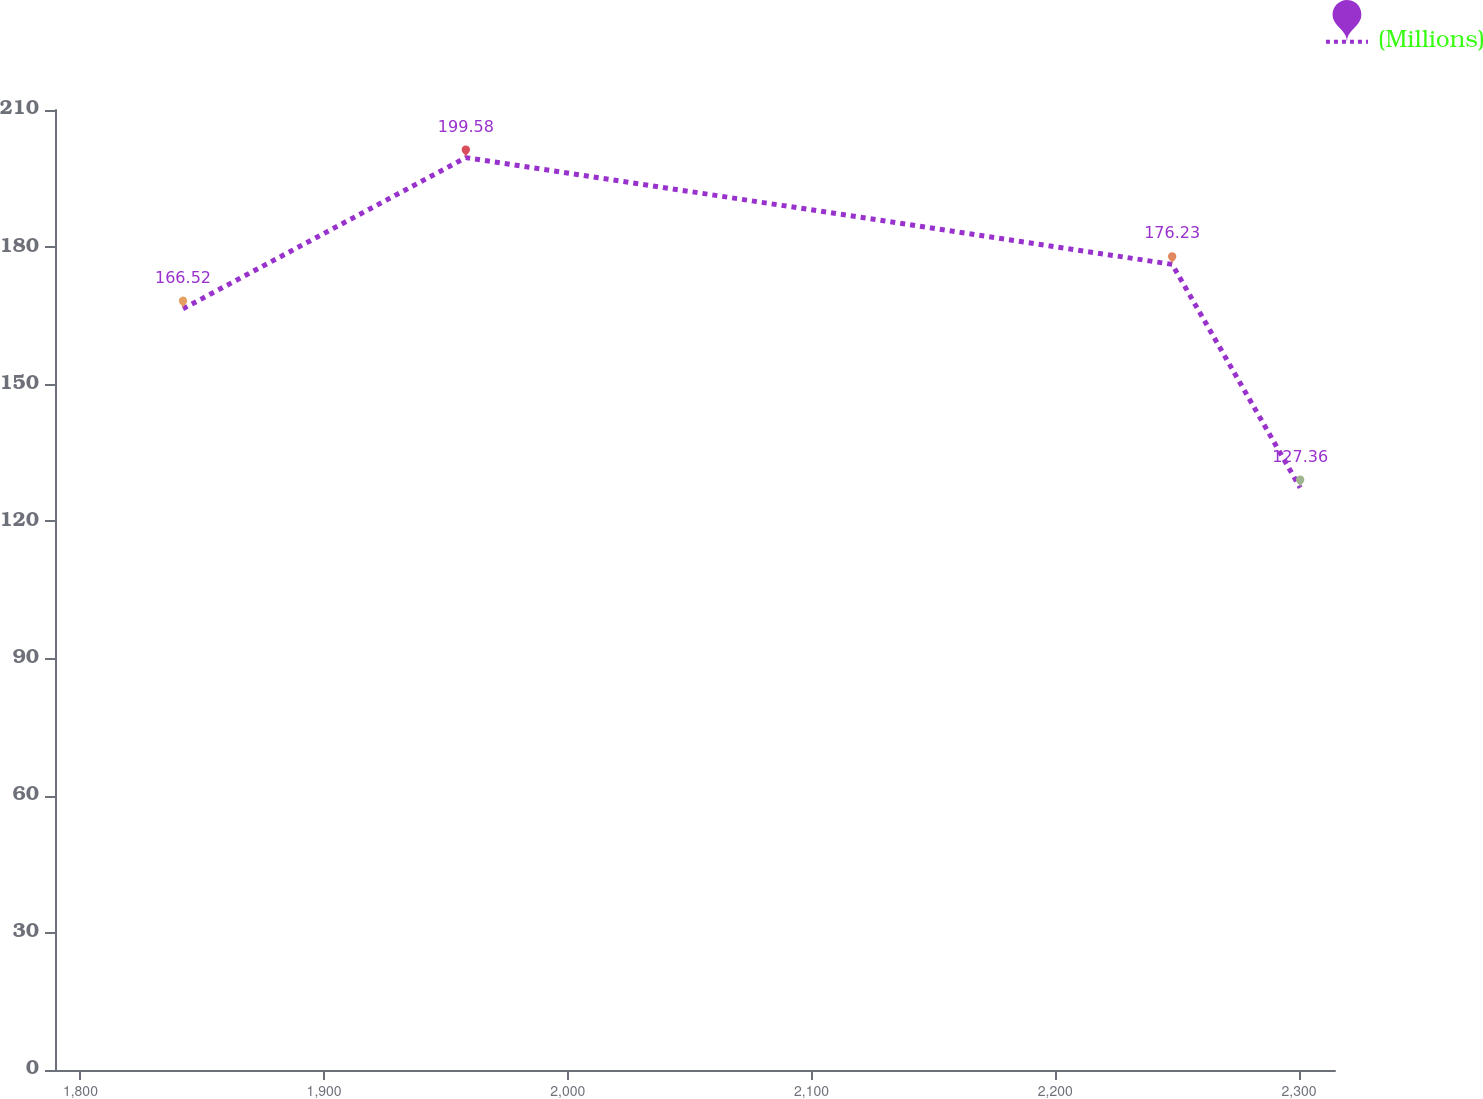Convert chart. <chart><loc_0><loc_0><loc_500><loc_500><line_chart><ecel><fcel>(Millions)<nl><fcel>1842.1<fcel>166.52<nl><fcel>1958.15<fcel>199.58<nl><fcel>2247.97<fcel>176.23<nl><fcel>2300.49<fcel>127.36<nl><fcel>2367.3<fcel>102.51<nl></chart> 